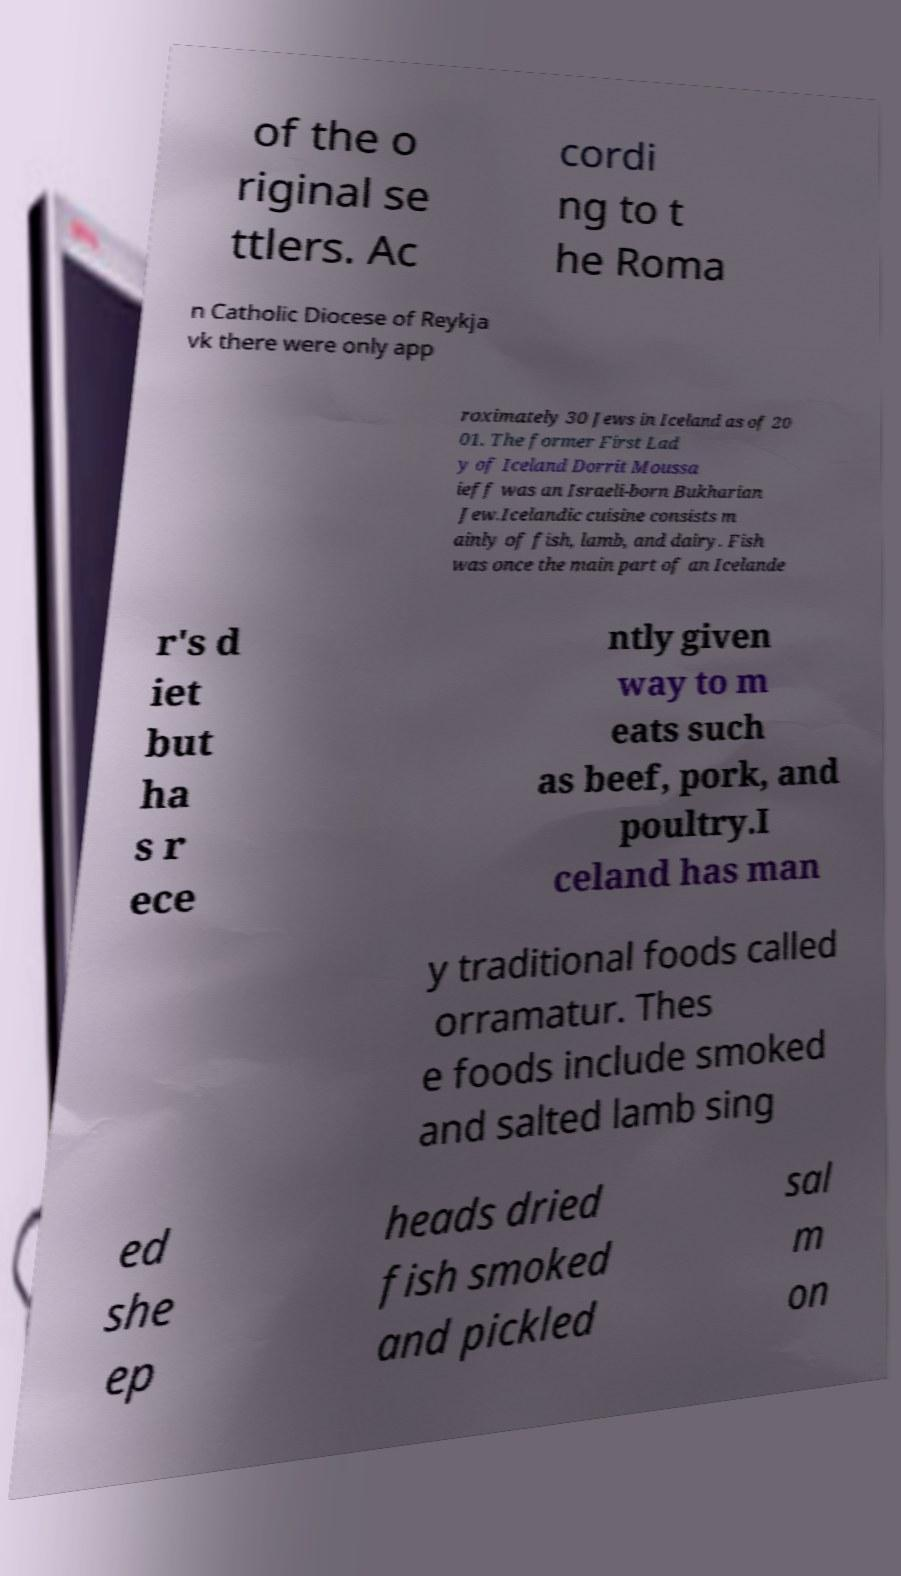Please read and relay the text visible in this image. What does it say? of the o riginal se ttlers. Ac cordi ng to t he Roma n Catholic Diocese of Reykja vk there were only app roximately 30 Jews in Iceland as of 20 01. The former First Lad y of Iceland Dorrit Moussa ieff was an Israeli-born Bukharian Jew.Icelandic cuisine consists m ainly of fish, lamb, and dairy. Fish was once the main part of an Icelande r's d iet but ha s r ece ntly given way to m eats such as beef, pork, and poultry.I celand has man y traditional foods called orramatur. Thes e foods include smoked and salted lamb sing ed she ep heads dried fish smoked and pickled sal m on 